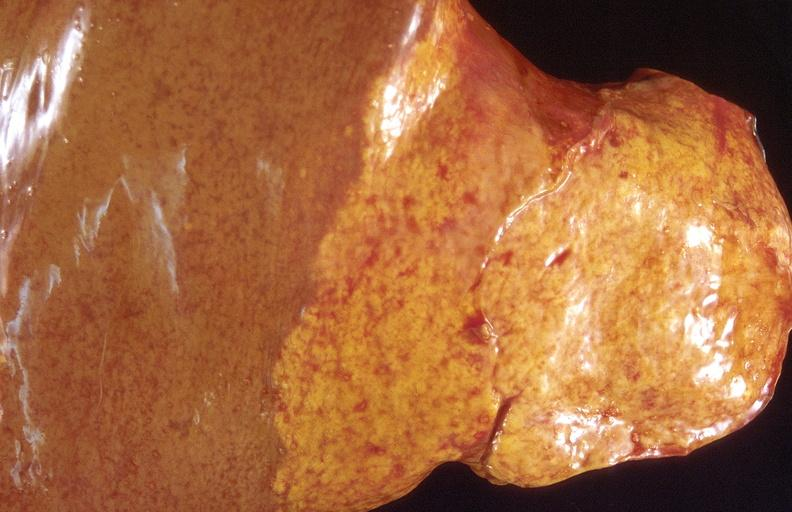s hepatobiliary present?
Answer the question using a single word or phrase. Yes 